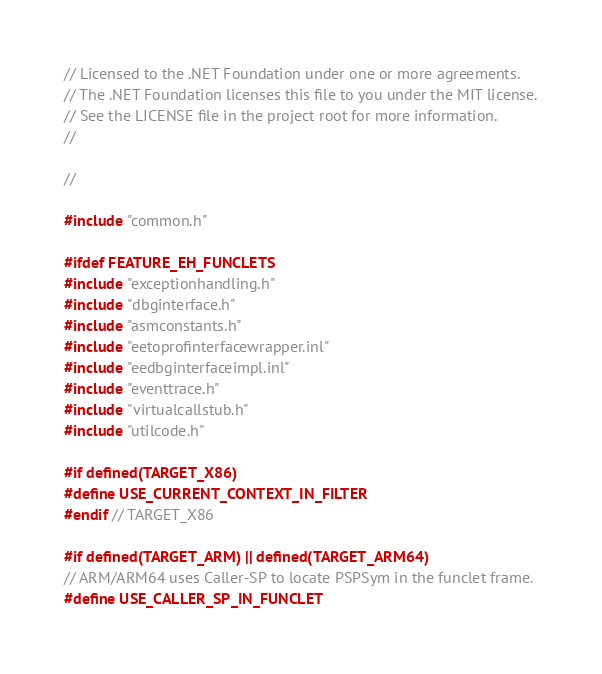Convert code to text. <code><loc_0><loc_0><loc_500><loc_500><_C++_>// Licensed to the .NET Foundation under one or more agreements.
// The .NET Foundation licenses this file to you under the MIT license.
// See the LICENSE file in the project root for more information.
//

//

#include "common.h"

#ifdef FEATURE_EH_FUNCLETS
#include "exceptionhandling.h"
#include "dbginterface.h"
#include "asmconstants.h"
#include "eetoprofinterfacewrapper.inl"
#include "eedbginterfaceimpl.inl"
#include "eventtrace.h"
#include "virtualcallstub.h"
#include "utilcode.h"

#if defined(TARGET_X86)
#define USE_CURRENT_CONTEXT_IN_FILTER
#endif // TARGET_X86

#if defined(TARGET_ARM) || defined(TARGET_ARM64)
// ARM/ARM64 uses Caller-SP to locate PSPSym in the funclet frame.
#define USE_CALLER_SP_IN_FUNCLET</code> 